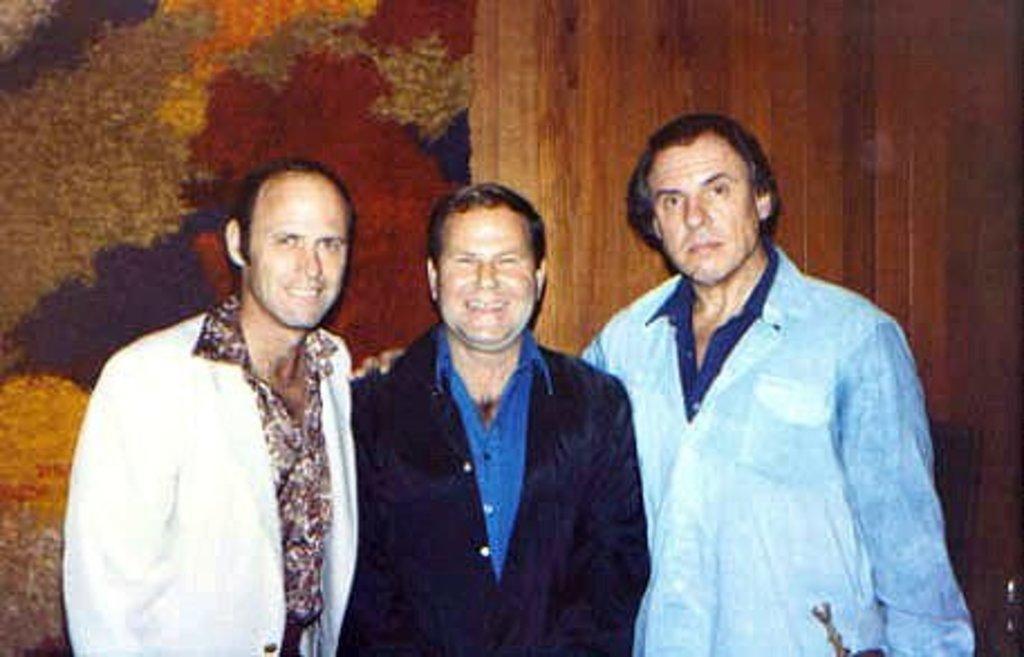Please provide a concise description of this image. In this image there are three persons standing as we can see in the bottom of this image and there is a wall in the background. 